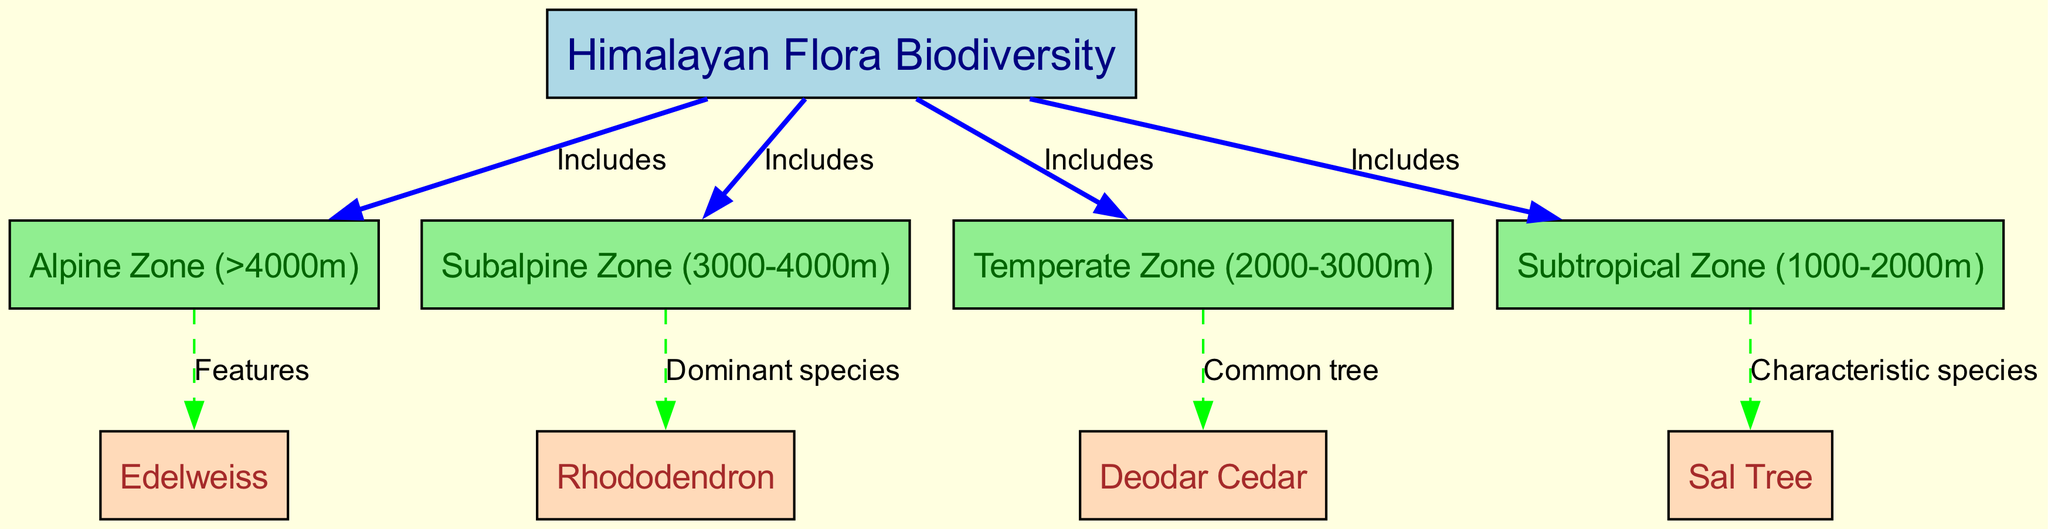What is the main topic of the diagram? The title of the diagram indicates that it is about Himalayan flora biodiversity.
Answer: Himalayan Flora Biodiversity How many zones are included in the Himalayan flora? The diagram lists four zones: Alpine, Subalpine, Temperate, and Subtropical, which can be counted directly from the node connections.
Answer: Four Which species is featured in the alpine zone? The connection from the alpine zone to the edelweiss node indicates that it is a feature of that zone.
Answer: Edelweiss What dominant species is found in the subalpine zone? The edge connection from the subalpine zone to the rhododendron node shows that rhododendron is the dominant species in that zone.
Answer: Rhododendron Which tree is common in the temperate zone? The edge from the temperate zone to the deodar cedar node indicates that deodar cedar is a common tree in this zone.
Answer: Deodar Cedar Which species is a characteristic species of the subtropical zone? The diagram connects the subtropical zone to the sal tree, indicating it is a characteristic species of that zone.
Answer: Sal Tree In which zone would you find deodar cedar? The diagram connects deodar cedar specifically to the temperate zone, showing that is where it can be found.
Answer: Temperate Zone What is the relationship between Himalayan flora and the alpine zone? The diagram shows that the alpine zone is included in the broader category of Himalayan flora.
Answer: Includes How many features are specifically noted in the alpine zone? Only one species, edelweiss, is noted as a feature of the alpine zone in the diagram.
Answer: One Which zone has rhododendron as its dominant species? The relationship from the subalpine zone to the rhododendron node signifies that the subalpine zone has rhododendron as its dominant species.
Answer: Subalpine Zone 